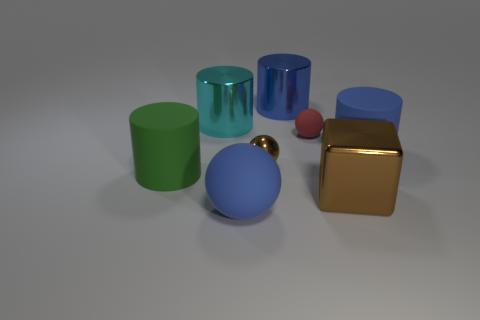Are there any other things that are the same shape as the big brown object?
Your response must be concise. No. There is a red rubber sphere; is its size the same as the blue rubber thing that is on the right side of the blue sphere?
Offer a terse response. No. Are there more cyan metallic spheres than large brown blocks?
Make the answer very short. No. Is the brown cube in front of the large green matte thing made of the same material as the big blue cylinder that is in front of the cyan cylinder?
Your answer should be very brief. No. What material is the big blue sphere?
Keep it short and to the point. Rubber. Is the number of brown shiny things left of the cyan cylinder greater than the number of small brown balls?
Keep it short and to the point. No. There is a big brown block that is in front of the large matte thing on the left side of the cyan cylinder; how many big blue cylinders are to the right of it?
Provide a succinct answer. 1. The object that is both in front of the small brown sphere and behind the metal block is made of what material?
Your answer should be very brief. Rubber. The metallic ball is what color?
Keep it short and to the point. Brown. Is the number of small brown shiny spheres that are behind the tiny brown metal sphere greater than the number of green objects behind the green thing?
Ensure brevity in your answer.  No. 